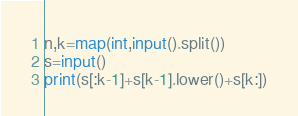<code> <loc_0><loc_0><loc_500><loc_500><_Python_>n,k=map(int,input().split())
s=input()
print(s[:k-1]+s[k-1].lower()+s[k:])</code> 